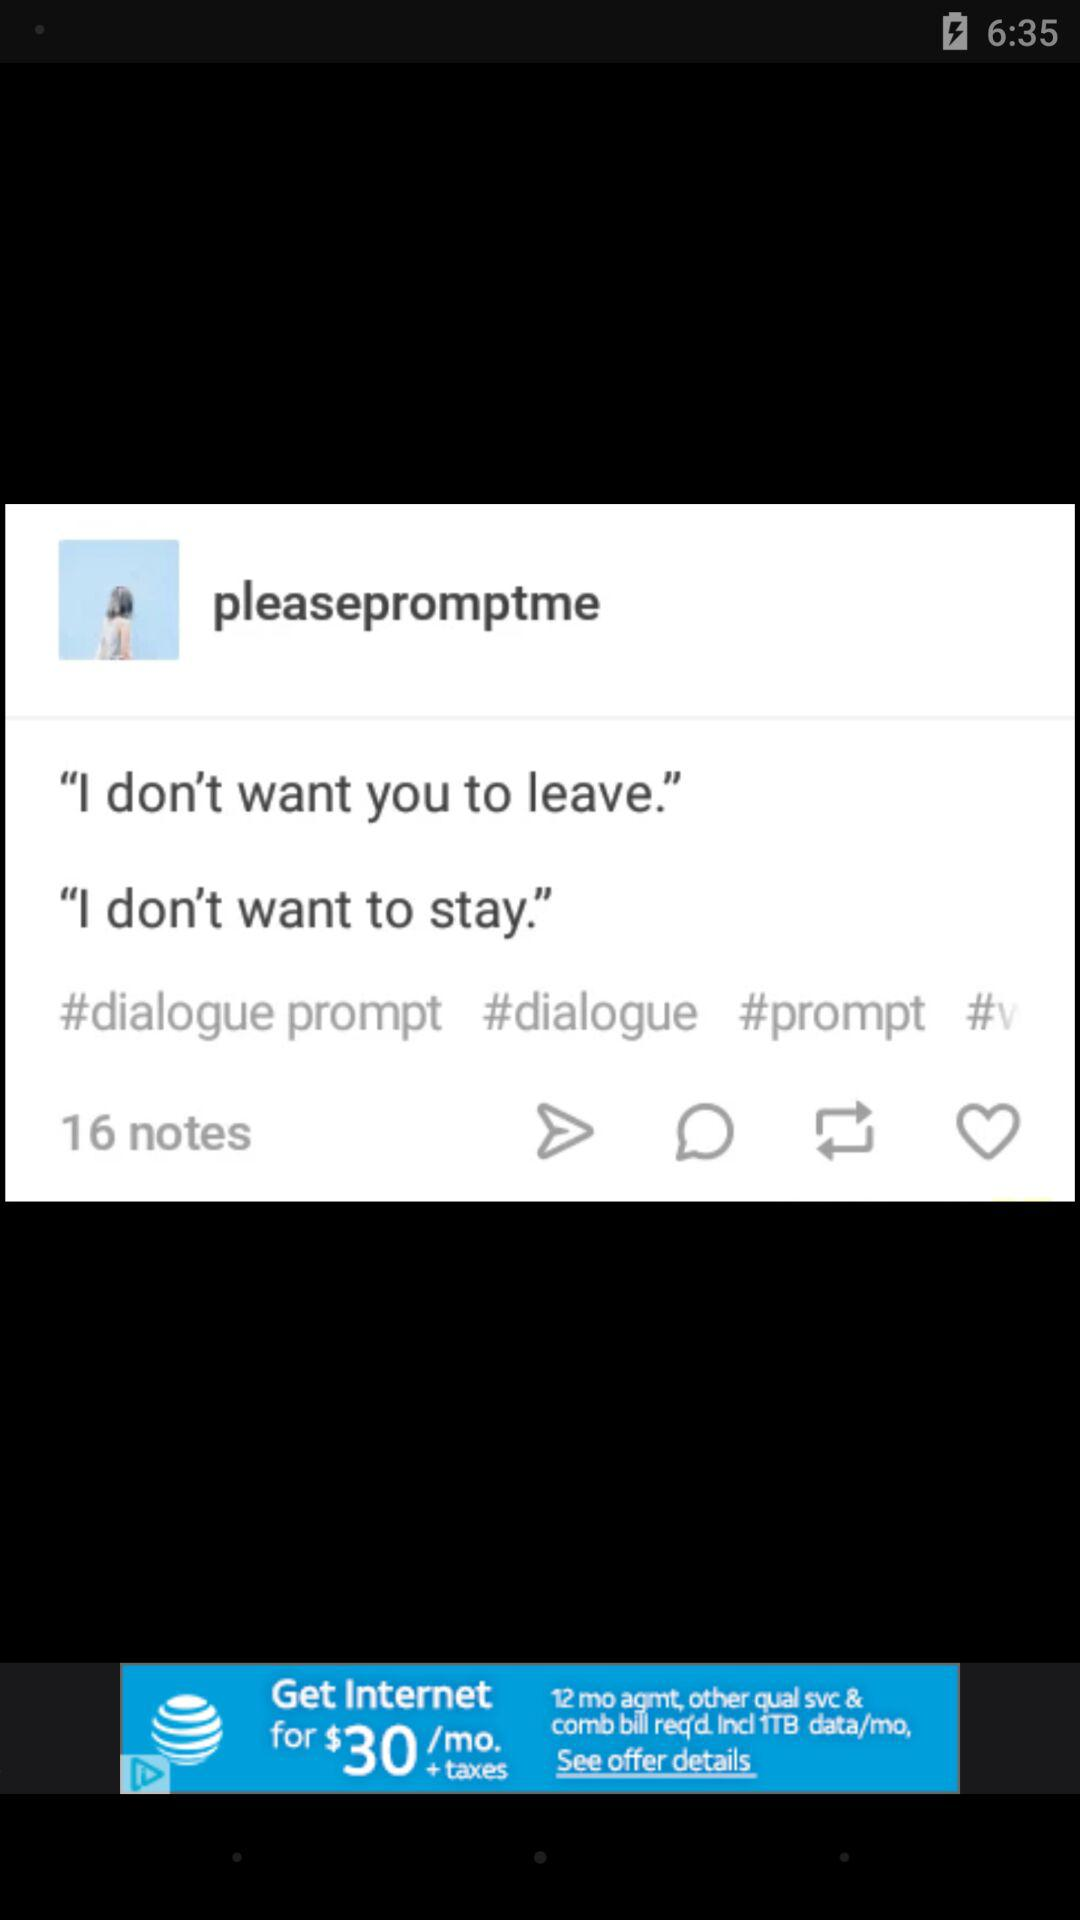How many prompts are there in total?
Answer the question using a single word or phrase. 2 